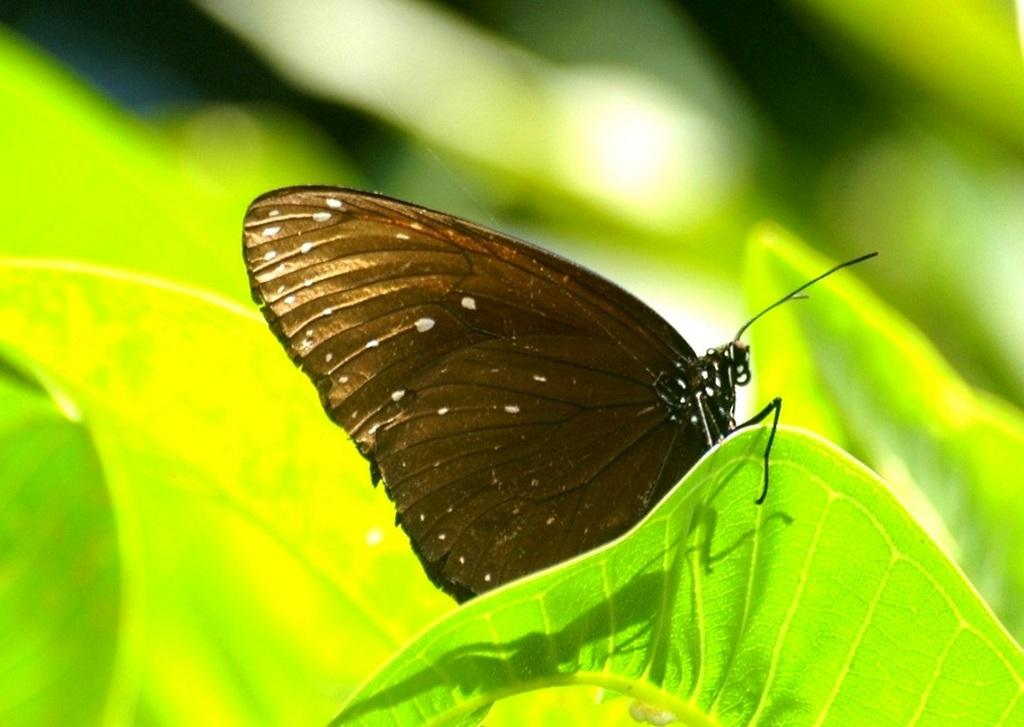What color are the leaves in the image? The leaves in the image are green. What type of insect is present in the image? There is a black color butterfly in the image. Where is the butterfly located in relation to the leaves? The butterfly is sitting on a green leaf. What type of fact can be seen on the desk in the image? There is no desk present in the image, so it is not possible to determine if there is a fact or any other object on it. 